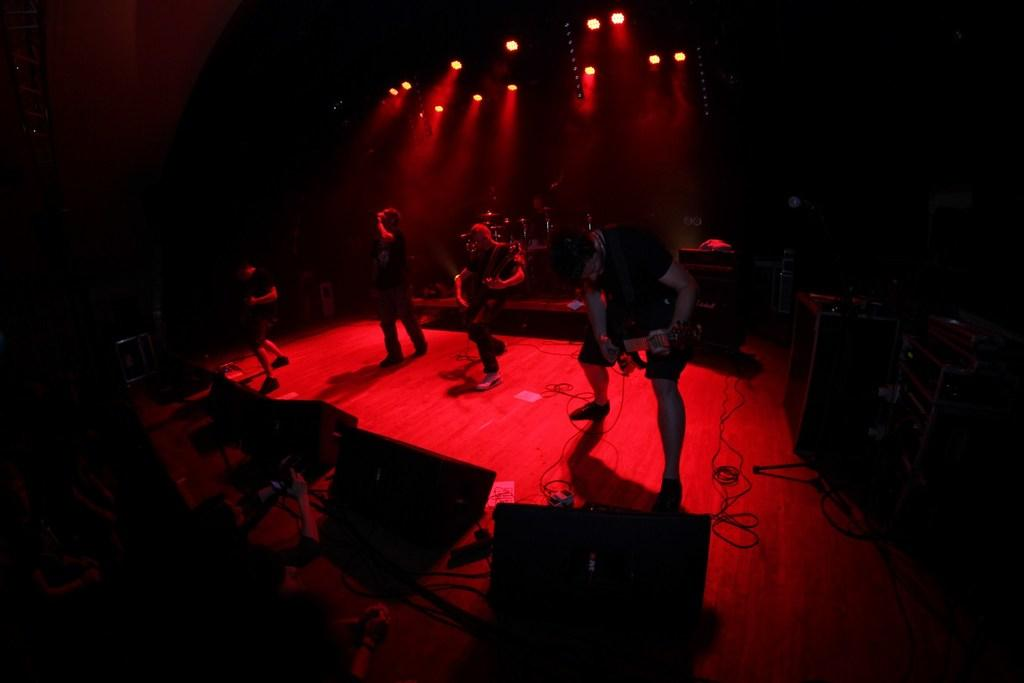What are the people on stage doing in the image? The people on stage are playing guitars. What equipment is present in the image to amplify the sound? Speakers are present in the image. What other musical instruments can be seen in the image? There are drums in the image. What is used to illuminate the stage in the image? Lights are present in the image. How would you describe the lighting conditions in the image? The background of the image is dark. What hobbies do the toes of the people on stage have in the image? There is no information about the toes of the people on stage in the image, and therefore no hobbies can be attributed to them. 